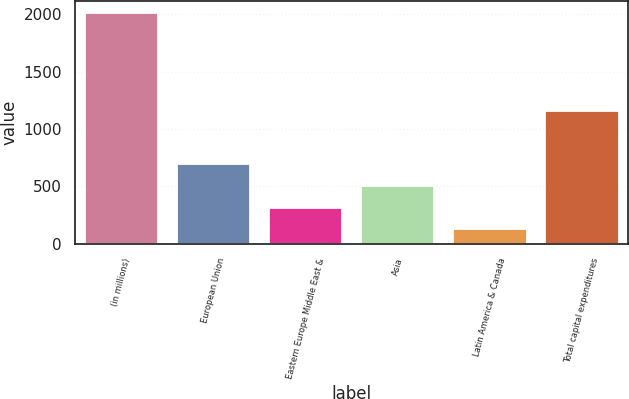Convert chart to OTSL. <chart><loc_0><loc_0><loc_500><loc_500><bar_chart><fcel>(in millions)<fcel>European Union<fcel>Eastern Europe Middle East &<fcel>Asia<fcel>Latin America & Canada<fcel>Total capital expenditures<nl><fcel>2014<fcel>691.7<fcel>313.9<fcel>502.8<fcel>125<fcel>1153<nl></chart> 